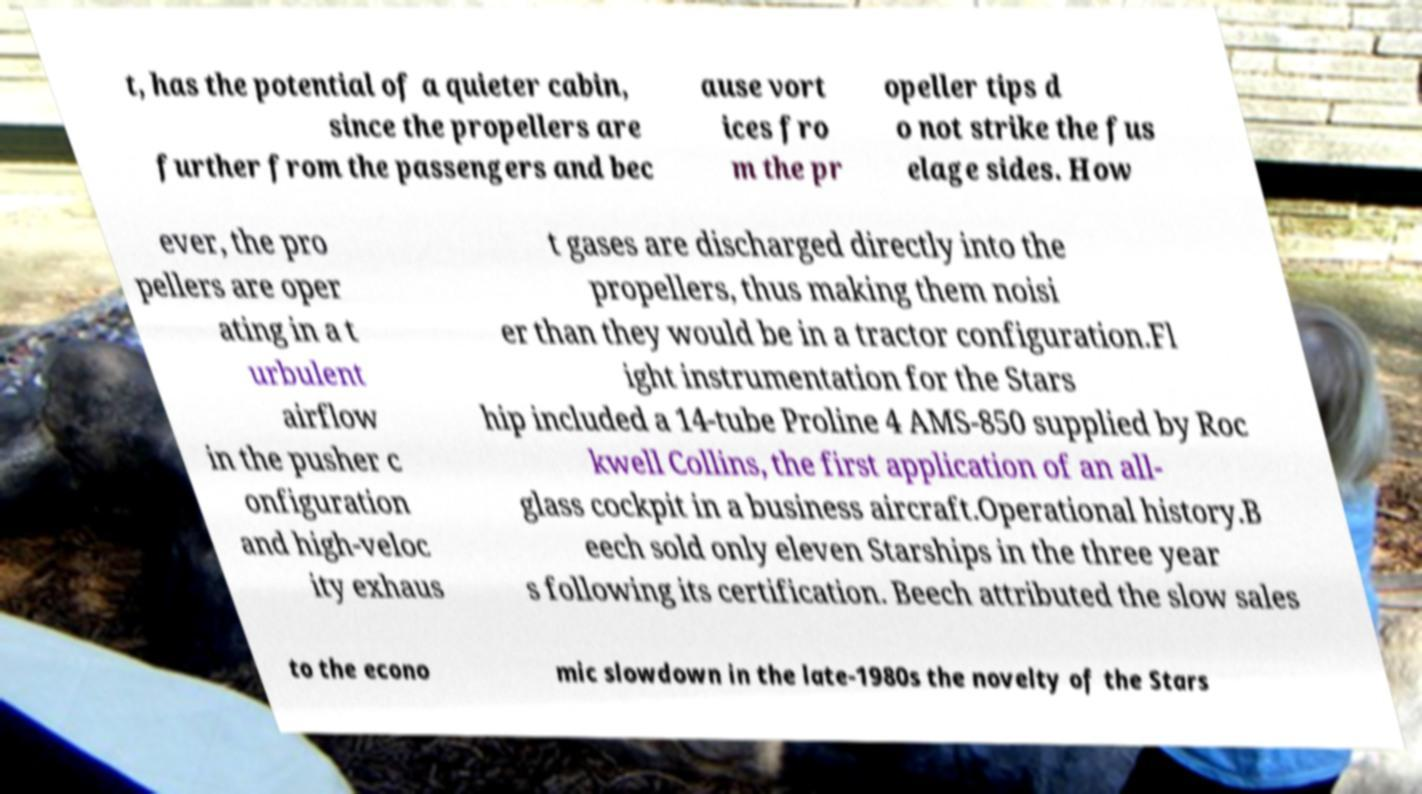There's text embedded in this image that I need extracted. Can you transcribe it verbatim? t, has the potential of a quieter cabin, since the propellers are further from the passengers and bec ause vort ices fro m the pr opeller tips d o not strike the fus elage sides. How ever, the pro pellers are oper ating in a t urbulent airflow in the pusher c onfiguration and high-veloc ity exhaus t gases are discharged directly into the propellers, thus making them noisi er than they would be in a tractor configuration.Fl ight instrumentation for the Stars hip included a 14-tube Proline 4 AMS-850 supplied by Roc kwell Collins, the first application of an all- glass cockpit in a business aircraft.Operational history.B eech sold only eleven Starships in the three year s following its certification. Beech attributed the slow sales to the econo mic slowdown in the late-1980s the novelty of the Stars 